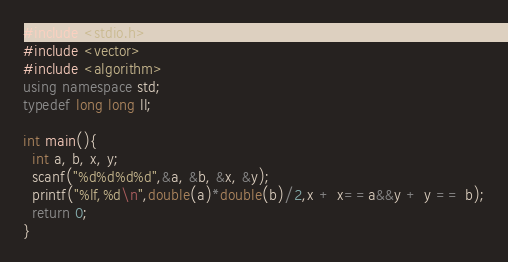Convert code to text. <code><loc_0><loc_0><loc_500><loc_500><_C++_>#include <stdio.h>
#include <vector>
#include <algorithm>
using namespace std;
typedef long long ll;

int main(){
  int a, b, x, y;
  scanf("%d%d%d%d",&a, &b, &x, &y);
  printf("%lf,%d\n",double(a)*double(b)/2,x + x==a&&y + y == b);
  return 0;
}</code> 